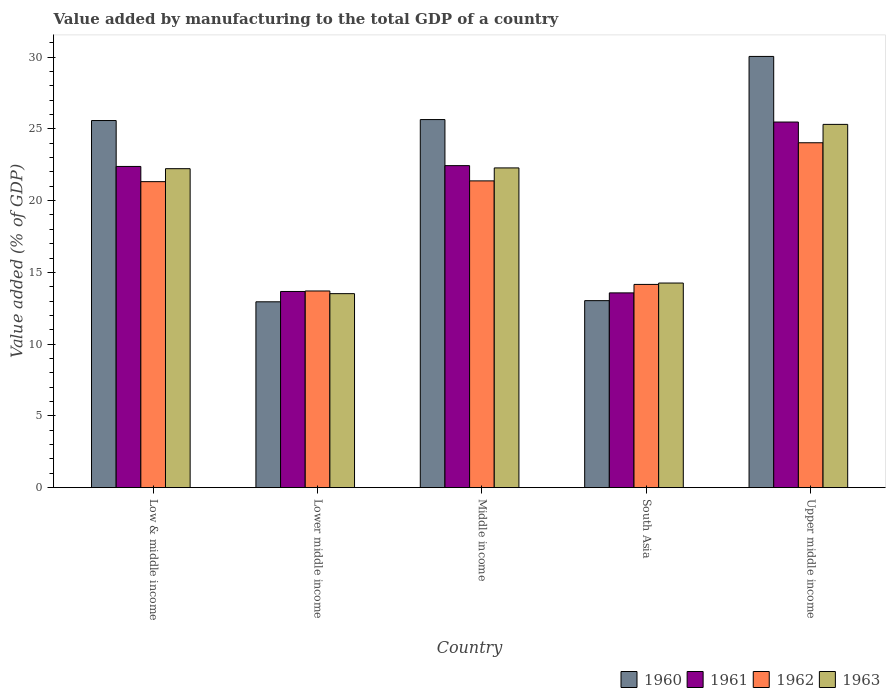How many different coloured bars are there?
Provide a succinct answer. 4. How many groups of bars are there?
Offer a terse response. 5. Are the number of bars per tick equal to the number of legend labels?
Offer a terse response. Yes. How many bars are there on the 2nd tick from the right?
Offer a very short reply. 4. What is the label of the 4th group of bars from the left?
Your answer should be very brief. South Asia. What is the value added by manufacturing to the total GDP in 1961 in Low & middle income?
Give a very brief answer. 22.38. Across all countries, what is the maximum value added by manufacturing to the total GDP in 1960?
Keep it short and to the point. 30.05. Across all countries, what is the minimum value added by manufacturing to the total GDP in 1962?
Your response must be concise. 13.7. In which country was the value added by manufacturing to the total GDP in 1961 maximum?
Offer a terse response. Upper middle income. In which country was the value added by manufacturing to the total GDP in 1963 minimum?
Your response must be concise. Lower middle income. What is the total value added by manufacturing to the total GDP in 1960 in the graph?
Your answer should be very brief. 107.25. What is the difference between the value added by manufacturing to the total GDP in 1960 in Low & middle income and that in Upper middle income?
Your answer should be very brief. -4.47. What is the difference between the value added by manufacturing to the total GDP in 1960 in South Asia and the value added by manufacturing to the total GDP in 1963 in Upper middle income?
Provide a succinct answer. -12.28. What is the average value added by manufacturing to the total GDP in 1960 per country?
Ensure brevity in your answer.  21.45. What is the difference between the value added by manufacturing to the total GDP of/in 1962 and value added by manufacturing to the total GDP of/in 1963 in Upper middle income?
Provide a succinct answer. -1.28. In how many countries, is the value added by manufacturing to the total GDP in 1963 greater than 15 %?
Keep it short and to the point. 3. What is the ratio of the value added by manufacturing to the total GDP in 1961 in Low & middle income to that in Upper middle income?
Your answer should be very brief. 0.88. Is the difference between the value added by manufacturing to the total GDP in 1962 in Low & middle income and Lower middle income greater than the difference between the value added by manufacturing to the total GDP in 1963 in Low & middle income and Lower middle income?
Keep it short and to the point. No. What is the difference between the highest and the second highest value added by manufacturing to the total GDP in 1961?
Offer a very short reply. 3.04. What is the difference between the highest and the lowest value added by manufacturing to the total GDP in 1962?
Provide a succinct answer. 10.33. Is the sum of the value added by manufacturing to the total GDP in 1962 in Lower middle income and Middle income greater than the maximum value added by manufacturing to the total GDP in 1960 across all countries?
Give a very brief answer. Yes. What does the 2nd bar from the left in Low & middle income represents?
Your answer should be very brief. 1961. Are all the bars in the graph horizontal?
Your response must be concise. No. How many countries are there in the graph?
Your response must be concise. 5. Does the graph contain any zero values?
Ensure brevity in your answer.  No. Does the graph contain grids?
Offer a very short reply. No. What is the title of the graph?
Your answer should be compact. Value added by manufacturing to the total GDP of a country. What is the label or title of the X-axis?
Make the answer very short. Country. What is the label or title of the Y-axis?
Ensure brevity in your answer.  Value added (% of GDP). What is the Value added (% of GDP) in 1960 in Low & middle income?
Your response must be concise. 25.58. What is the Value added (% of GDP) of 1961 in Low & middle income?
Your response must be concise. 22.38. What is the Value added (% of GDP) in 1962 in Low & middle income?
Make the answer very short. 21.32. What is the Value added (% of GDP) in 1963 in Low & middle income?
Make the answer very short. 22.22. What is the Value added (% of GDP) in 1960 in Lower middle income?
Offer a very short reply. 12.95. What is the Value added (% of GDP) in 1961 in Lower middle income?
Offer a very short reply. 13.67. What is the Value added (% of GDP) in 1962 in Lower middle income?
Provide a succinct answer. 13.7. What is the Value added (% of GDP) of 1963 in Lower middle income?
Provide a short and direct response. 13.52. What is the Value added (% of GDP) of 1960 in Middle income?
Offer a very short reply. 25.65. What is the Value added (% of GDP) in 1961 in Middle income?
Keep it short and to the point. 22.44. What is the Value added (% of GDP) in 1962 in Middle income?
Your answer should be compact. 21.37. What is the Value added (% of GDP) in 1963 in Middle income?
Your answer should be compact. 22.28. What is the Value added (% of GDP) in 1960 in South Asia?
Make the answer very short. 13.03. What is the Value added (% of GDP) in 1961 in South Asia?
Make the answer very short. 13.57. What is the Value added (% of GDP) in 1962 in South Asia?
Make the answer very short. 14.16. What is the Value added (% of GDP) of 1963 in South Asia?
Give a very brief answer. 14.26. What is the Value added (% of GDP) of 1960 in Upper middle income?
Ensure brevity in your answer.  30.05. What is the Value added (% of GDP) of 1961 in Upper middle income?
Provide a succinct answer. 25.47. What is the Value added (% of GDP) of 1962 in Upper middle income?
Offer a very short reply. 24.03. What is the Value added (% of GDP) of 1963 in Upper middle income?
Keep it short and to the point. 25.31. Across all countries, what is the maximum Value added (% of GDP) of 1960?
Make the answer very short. 30.05. Across all countries, what is the maximum Value added (% of GDP) in 1961?
Provide a succinct answer. 25.47. Across all countries, what is the maximum Value added (% of GDP) in 1962?
Offer a terse response. 24.03. Across all countries, what is the maximum Value added (% of GDP) in 1963?
Your response must be concise. 25.31. Across all countries, what is the minimum Value added (% of GDP) in 1960?
Make the answer very short. 12.95. Across all countries, what is the minimum Value added (% of GDP) in 1961?
Provide a succinct answer. 13.57. Across all countries, what is the minimum Value added (% of GDP) of 1962?
Ensure brevity in your answer.  13.7. Across all countries, what is the minimum Value added (% of GDP) in 1963?
Your response must be concise. 13.52. What is the total Value added (% of GDP) of 1960 in the graph?
Make the answer very short. 107.25. What is the total Value added (% of GDP) in 1961 in the graph?
Provide a short and direct response. 97.53. What is the total Value added (% of GDP) of 1962 in the graph?
Offer a very short reply. 94.59. What is the total Value added (% of GDP) in 1963 in the graph?
Ensure brevity in your answer.  97.58. What is the difference between the Value added (% of GDP) in 1960 in Low & middle income and that in Lower middle income?
Your response must be concise. 12.63. What is the difference between the Value added (% of GDP) of 1961 in Low & middle income and that in Lower middle income?
Provide a short and direct response. 8.71. What is the difference between the Value added (% of GDP) in 1962 in Low & middle income and that in Lower middle income?
Provide a short and direct response. 7.62. What is the difference between the Value added (% of GDP) of 1963 in Low & middle income and that in Lower middle income?
Offer a very short reply. 8.71. What is the difference between the Value added (% of GDP) in 1960 in Low & middle income and that in Middle income?
Provide a short and direct response. -0.07. What is the difference between the Value added (% of GDP) in 1961 in Low & middle income and that in Middle income?
Provide a succinct answer. -0.06. What is the difference between the Value added (% of GDP) in 1962 in Low & middle income and that in Middle income?
Offer a very short reply. -0.05. What is the difference between the Value added (% of GDP) in 1963 in Low & middle income and that in Middle income?
Offer a terse response. -0.05. What is the difference between the Value added (% of GDP) of 1960 in Low & middle income and that in South Asia?
Provide a succinct answer. 12.55. What is the difference between the Value added (% of GDP) of 1961 in Low & middle income and that in South Asia?
Give a very brief answer. 8.81. What is the difference between the Value added (% of GDP) of 1962 in Low & middle income and that in South Asia?
Provide a short and direct response. 7.16. What is the difference between the Value added (% of GDP) in 1963 in Low & middle income and that in South Asia?
Your answer should be very brief. 7.97. What is the difference between the Value added (% of GDP) of 1960 in Low & middle income and that in Upper middle income?
Provide a short and direct response. -4.47. What is the difference between the Value added (% of GDP) in 1961 in Low & middle income and that in Upper middle income?
Offer a terse response. -3.09. What is the difference between the Value added (% of GDP) in 1962 in Low & middle income and that in Upper middle income?
Provide a succinct answer. -2.71. What is the difference between the Value added (% of GDP) of 1963 in Low & middle income and that in Upper middle income?
Your answer should be compact. -3.09. What is the difference between the Value added (% of GDP) of 1960 in Lower middle income and that in Middle income?
Ensure brevity in your answer.  -12.7. What is the difference between the Value added (% of GDP) of 1961 in Lower middle income and that in Middle income?
Give a very brief answer. -8.77. What is the difference between the Value added (% of GDP) in 1962 in Lower middle income and that in Middle income?
Your answer should be compact. -7.67. What is the difference between the Value added (% of GDP) of 1963 in Lower middle income and that in Middle income?
Provide a succinct answer. -8.76. What is the difference between the Value added (% of GDP) in 1960 in Lower middle income and that in South Asia?
Your response must be concise. -0.08. What is the difference between the Value added (% of GDP) in 1961 in Lower middle income and that in South Asia?
Keep it short and to the point. 0.1. What is the difference between the Value added (% of GDP) of 1962 in Lower middle income and that in South Asia?
Ensure brevity in your answer.  -0.46. What is the difference between the Value added (% of GDP) in 1963 in Lower middle income and that in South Asia?
Offer a terse response. -0.74. What is the difference between the Value added (% of GDP) in 1960 in Lower middle income and that in Upper middle income?
Offer a very short reply. -17.1. What is the difference between the Value added (% of GDP) in 1961 in Lower middle income and that in Upper middle income?
Give a very brief answer. -11.81. What is the difference between the Value added (% of GDP) of 1962 in Lower middle income and that in Upper middle income?
Your response must be concise. -10.33. What is the difference between the Value added (% of GDP) of 1963 in Lower middle income and that in Upper middle income?
Your answer should be compact. -11.79. What is the difference between the Value added (% of GDP) in 1960 in Middle income and that in South Asia?
Offer a terse response. 12.62. What is the difference between the Value added (% of GDP) in 1961 in Middle income and that in South Asia?
Give a very brief answer. 8.87. What is the difference between the Value added (% of GDP) in 1962 in Middle income and that in South Asia?
Make the answer very short. 7.21. What is the difference between the Value added (% of GDP) in 1963 in Middle income and that in South Asia?
Provide a short and direct response. 8.02. What is the difference between the Value added (% of GDP) of 1960 in Middle income and that in Upper middle income?
Ensure brevity in your answer.  -4.4. What is the difference between the Value added (% of GDP) of 1961 in Middle income and that in Upper middle income?
Offer a very short reply. -3.04. What is the difference between the Value added (% of GDP) in 1962 in Middle income and that in Upper middle income?
Provide a succinct answer. -2.66. What is the difference between the Value added (% of GDP) in 1963 in Middle income and that in Upper middle income?
Offer a terse response. -3.03. What is the difference between the Value added (% of GDP) of 1960 in South Asia and that in Upper middle income?
Ensure brevity in your answer.  -17.02. What is the difference between the Value added (% of GDP) in 1961 in South Asia and that in Upper middle income?
Give a very brief answer. -11.9. What is the difference between the Value added (% of GDP) in 1962 in South Asia and that in Upper middle income?
Provide a short and direct response. -9.87. What is the difference between the Value added (% of GDP) of 1963 in South Asia and that in Upper middle income?
Your answer should be compact. -11.05. What is the difference between the Value added (% of GDP) in 1960 in Low & middle income and the Value added (% of GDP) in 1961 in Lower middle income?
Provide a succinct answer. 11.91. What is the difference between the Value added (% of GDP) in 1960 in Low & middle income and the Value added (% of GDP) in 1962 in Lower middle income?
Your answer should be compact. 11.88. What is the difference between the Value added (% of GDP) in 1960 in Low & middle income and the Value added (% of GDP) in 1963 in Lower middle income?
Your answer should be compact. 12.06. What is the difference between the Value added (% of GDP) in 1961 in Low & middle income and the Value added (% of GDP) in 1962 in Lower middle income?
Ensure brevity in your answer.  8.68. What is the difference between the Value added (% of GDP) of 1961 in Low & middle income and the Value added (% of GDP) of 1963 in Lower middle income?
Offer a very short reply. 8.86. What is the difference between the Value added (% of GDP) of 1962 in Low & middle income and the Value added (% of GDP) of 1963 in Lower middle income?
Your response must be concise. 7.8. What is the difference between the Value added (% of GDP) in 1960 in Low & middle income and the Value added (% of GDP) in 1961 in Middle income?
Make the answer very short. 3.14. What is the difference between the Value added (% of GDP) of 1960 in Low & middle income and the Value added (% of GDP) of 1962 in Middle income?
Provide a succinct answer. 4.21. What is the difference between the Value added (% of GDP) in 1960 in Low & middle income and the Value added (% of GDP) in 1963 in Middle income?
Your answer should be compact. 3.3. What is the difference between the Value added (% of GDP) in 1961 in Low & middle income and the Value added (% of GDP) in 1962 in Middle income?
Your response must be concise. 1.01. What is the difference between the Value added (% of GDP) in 1961 in Low & middle income and the Value added (% of GDP) in 1963 in Middle income?
Keep it short and to the point. 0.1. What is the difference between the Value added (% of GDP) in 1962 in Low & middle income and the Value added (% of GDP) in 1963 in Middle income?
Your answer should be very brief. -0.96. What is the difference between the Value added (% of GDP) of 1960 in Low & middle income and the Value added (% of GDP) of 1961 in South Asia?
Your answer should be compact. 12.01. What is the difference between the Value added (% of GDP) in 1960 in Low & middle income and the Value added (% of GDP) in 1962 in South Asia?
Ensure brevity in your answer.  11.42. What is the difference between the Value added (% of GDP) of 1960 in Low & middle income and the Value added (% of GDP) of 1963 in South Asia?
Your answer should be very brief. 11.32. What is the difference between the Value added (% of GDP) of 1961 in Low & middle income and the Value added (% of GDP) of 1962 in South Asia?
Give a very brief answer. 8.22. What is the difference between the Value added (% of GDP) in 1961 in Low & middle income and the Value added (% of GDP) in 1963 in South Asia?
Your response must be concise. 8.12. What is the difference between the Value added (% of GDP) of 1962 in Low & middle income and the Value added (% of GDP) of 1963 in South Asia?
Ensure brevity in your answer.  7.06. What is the difference between the Value added (% of GDP) in 1960 in Low & middle income and the Value added (% of GDP) in 1961 in Upper middle income?
Your answer should be compact. 0.11. What is the difference between the Value added (% of GDP) of 1960 in Low & middle income and the Value added (% of GDP) of 1962 in Upper middle income?
Provide a short and direct response. 1.55. What is the difference between the Value added (% of GDP) of 1960 in Low & middle income and the Value added (% of GDP) of 1963 in Upper middle income?
Offer a very short reply. 0.27. What is the difference between the Value added (% of GDP) of 1961 in Low & middle income and the Value added (% of GDP) of 1962 in Upper middle income?
Provide a succinct answer. -1.65. What is the difference between the Value added (% of GDP) of 1961 in Low & middle income and the Value added (% of GDP) of 1963 in Upper middle income?
Your answer should be compact. -2.93. What is the difference between the Value added (% of GDP) of 1962 in Low & middle income and the Value added (% of GDP) of 1963 in Upper middle income?
Make the answer very short. -3.99. What is the difference between the Value added (% of GDP) in 1960 in Lower middle income and the Value added (% of GDP) in 1961 in Middle income?
Offer a terse response. -9.49. What is the difference between the Value added (% of GDP) in 1960 in Lower middle income and the Value added (% of GDP) in 1962 in Middle income?
Make the answer very short. -8.43. What is the difference between the Value added (% of GDP) in 1960 in Lower middle income and the Value added (% of GDP) in 1963 in Middle income?
Offer a terse response. -9.33. What is the difference between the Value added (% of GDP) of 1961 in Lower middle income and the Value added (% of GDP) of 1962 in Middle income?
Your answer should be very brief. -7.71. What is the difference between the Value added (% of GDP) of 1961 in Lower middle income and the Value added (% of GDP) of 1963 in Middle income?
Your answer should be compact. -8.61. What is the difference between the Value added (% of GDP) of 1962 in Lower middle income and the Value added (% of GDP) of 1963 in Middle income?
Your answer should be compact. -8.57. What is the difference between the Value added (% of GDP) of 1960 in Lower middle income and the Value added (% of GDP) of 1961 in South Asia?
Offer a very short reply. -0.62. What is the difference between the Value added (% of GDP) of 1960 in Lower middle income and the Value added (% of GDP) of 1962 in South Asia?
Your response must be concise. -1.21. What is the difference between the Value added (% of GDP) in 1960 in Lower middle income and the Value added (% of GDP) in 1963 in South Asia?
Provide a succinct answer. -1.31. What is the difference between the Value added (% of GDP) of 1961 in Lower middle income and the Value added (% of GDP) of 1962 in South Asia?
Your answer should be very brief. -0.49. What is the difference between the Value added (% of GDP) of 1961 in Lower middle income and the Value added (% of GDP) of 1963 in South Asia?
Provide a short and direct response. -0.59. What is the difference between the Value added (% of GDP) in 1962 in Lower middle income and the Value added (% of GDP) in 1963 in South Asia?
Offer a terse response. -0.55. What is the difference between the Value added (% of GDP) of 1960 in Lower middle income and the Value added (% of GDP) of 1961 in Upper middle income?
Offer a very short reply. -12.53. What is the difference between the Value added (% of GDP) in 1960 in Lower middle income and the Value added (% of GDP) in 1962 in Upper middle income?
Give a very brief answer. -11.08. What is the difference between the Value added (% of GDP) of 1960 in Lower middle income and the Value added (% of GDP) of 1963 in Upper middle income?
Offer a terse response. -12.36. What is the difference between the Value added (% of GDP) of 1961 in Lower middle income and the Value added (% of GDP) of 1962 in Upper middle income?
Your answer should be compact. -10.36. What is the difference between the Value added (% of GDP) of 1961 in Lower middle income and the Value added (% of GDP) of 1963 in Upper middle income?
Provide a succinct answer. -11.64. What is the difference between the Value added (% of GDP) of 1962 in Lower middle income and the Value added (% of GDP) of 1963 in Upper middle income?
Your answer should be compact. -11.61. What is the difference between the Value added (% of GDP) of 1960 in Middle income and the Value added (% of GDP) of 1961 in South Asia?
Your answer should be compact. 12.08. What is the difference between the Value added (% of GDP) in 1960 in Middle income and the Value added (% of GDP) in 1962 in South Asia?
Make the answer very short. 11.49. What is the difference between the Value added (% of GDP) of 1960 in Middle income and the Value added (% of GDP) of 1963 in South Asia?
Ensure brevity in your answer.  11.39. What is the difference between the Value added (% of GDP) in 1961 in Middle income and the Value added (% of GDP) in 1962 in South Asia?
Your answer should be very brief. 8.28. What is the difference between the Value added (% of GDP) of 1961 in Middle income and the Value added (% of GDP) of 1963 in South Asia?
Offer a terse response. 8.18. What is the difference between the Value added (% of GDP) of 1962 in Middle income and the Value added (% of GDP) of 1963 in South Asia?
Your response must be concise. 7.12. What is the difference between the Value added (% of GDP) in 1960 in Middle income and the Value added (% of GDP) in 1961 in Upper middle income?
Your answer should be compact. 0.17. What is the difference between the Value added (% of GDP) in 1960 in Middle income and the Value added (% of GDP) in 1962 in Upper middle income?
Your answer should be very brief. 1.62. What is the difference between the Value added (% of GDP) of 1960 in Middle income and the Value added (% of GDP) of 1963 in Upper middle income?
Your answer should be compact. 0.34. What is the difference between the Value added (% of GDP) of 1961 in Middle income and the Value added (% of GDP) of 1962 in Upper middle income?
Offer a terse response. -1.59. What is the difference between the Value added (% of GDP) of 1961 in Middle income and the Value added (% of GDP) of 1963 in Upper middle income?
Give a very brief answer. -2.87. What is the difference between the Value added (% of GDP) in 1962 in Middle income and the Value added (% of GDP) in 1963 in Upper middle income?
Keep it short and to the point. -3.94. What is the difference between the Value added (% of GDP) of 1960 in South Asia and the Value added (% of GDP) of 1961 in Upper middle income?
Make the answer very short. -12.44. What is the difference between the Value added (% of GDP) in 1960 in South Asia and the Value added (% of GDP) in 1962 in Upper middle income?
Your response must be concise. -11. What is the difference between the Value added (% of GDP) in 1960 in South Asia and the Value added (% of GDP) in 1963 in Upper middle income?
Provide a succinct answer. -12.28. What is the difference between the Value added (% of GDP) of 1961 in South Asia and the Value added (% of GDP) of 1962 in Upper middle income?
Provide a short and direct response. -10.46. What is the difference between the Value added (% of GDP) of 1961 in South Asia and the Value added (% of GDP) of 1963 in Upper middle income?
Your answer should be compact. -11.74. What is the difference between the Value added (% of GDP) of 1962 in South Asia and the Value added (% of GDP) of 1963 in Upper middle income?
Your response must be concise. -11.15. What is the average Value added (% of GDP) of 1960 per country?
Make the answer very short. 21.45. What is the average Value added (% of GDP) of 1961 per country?
Offer a very short reply. 19.51. What is the average Value added (% of GDP) in 1962 per country?
Provide a succinct answer. 18.92. What is the average Value added (% of GDP) of 1963 per country?
Make the answer very short. 19.52. What is the difference between the Value added (% of GDP) in 1960 and Value added (% of GDP) in 1961 in Low & middle income?
Keep it short and to the point. 3.2. What is the difference between the Value added (% of GDP) in 1960 and Value added (% of GDP) in 1962 in Low & middle income?
Your response must be concise. 4.26. What is the difference between the Value added (% of GDP) in 1960 and Value added (% of GDP) in 1963 in Low & middle income?
Provide a succinct answer. 3.35. What is the difference between the Value added (% of GDP) of 1961 and Value added (% of GDP) of 1962 in Low & middle income?
Your response must be concise. 1.06. What is the difference between the Value added (% of GDP) in 1961 and Value added (% of GDP) in 1963 in Low & middle income?
Your response must be concise. 0.16. What is the difference between the Value added (% of GDP) of 1962 and Value added (% of GDP) of 1963 in Low & middle income?
Give a very brief answer. -0.9. What is the difference between the Value added (% of GDP) of 1960 and Value added (% of GDP) of 1961 in Lower middle income?
Give a very brief answer. -0.72. What is the difference between the Value added (% of GDP) in 1960 and Value added (% of GDP) in 1962 in Lower middle income?
Provide a succinct answer. -0.75. What is the difference between the Value added (% of GDP) in 1960 and Value added (% of GDP) in 1963 in Lower middle income?
Offer a terse response. -0.57. What is the difference between the Value added (% of GDP) in 1961 and Value added (% of GDP) in 1962 in Lower middle income?
Your response must be concise. -0.04. What is the difference between the Value added (% of GDP) of 1961 and Value added (% of GDP) of 1963 in Lower middle income?
Your answer should be compact. 0.15. What is the difference between the Value added (% of GDP) in 1962 and Value added (% of GDP) in 1963 in Lower middle income?
Provide a short and direct response. 0.19. What is the difference between the Value added (% of GDP) in 1960 and Value added (% of GDP) in 1961 in Middle income?
Offer a terse response. 3.21. What is the difference between the Value added (% of GDP) in 1960 and Value added (% of GDP) in 1962 in Middle income?
Provide a succinct answer. 4.27. What is the difference between the Value added (% of GDP) in 1960 and Value added (% of GDP) in 1963 in Middle income?
Your answer should be very brief. 3.37. What is the difference between the Value added (% of GDP) in 1961 and Value added (% of GDP) in 1962 in Middle income?
Your answer should be very brief. 1.06. What is the difference between the Value added (% of GDP) of 1961 and Value added (% of GDP) of 1963 in Middle income?
Your answer should be very brief. 0.16. What is the difference between the Value added (% of GDP) in 1962 and Value added (% of GDP) in 1963 in Middle income?
Your answer should be very brief. -0.9. What is the difference between the Value added (% of GDP) of 1960 and Value added (% of GDP) of 1961 in South Asia?
Offer a very short reply. -0.54. What is the difference between the Value added (% of GDP) of 1960 and Value added (% of GDP) of 1962 in South Asia?
Provide a short and direct response. -1.13. What is the difference between the Value added (% of GDP) in 1960 and Value added (% of GDP) in 1963 in South Asia?
Provide a short and direct response. -1.23. What is the difference between the Value added (% of GDP) in 1961 and Value added (% of GDP) in 1962 in South Asia?
Provide a succinct answer. -0.59. What is the difference between the Value added (% of GDP) in 1961 and Value added (% of GDP) in 1963 in South Asia?
Your answer should be very brief. -0.69. What is the difference between the Value added (% of GDP) of 1962 and Value added (% of GDP) of 1963 in South Asia?
Give a very brief answer. -0.1. What is the difference between the Value added (% of GDP) in 1960 and Value added (% of GDP) in 1961 in Upper middle income?
Keep it short and to the point. 4.57. What is the difference between the Value added (% of GDP) of 1960 and Value added (% of GDP) of 1962 in Upper middle income?
Offer a very short reply. 6.01. What is the difference between the Value added (% of GDP) in 1960 and Value added (% of GDP) in 1963 in Upper middle income?
Offer a very short reply. 4.73. What is the difference between the Value added (% of GDP) in 1961 and Value added (% of GDP) in 1962 in Upper middle income?
Your answer should be very brief. 1.44. What is the difference between the Value added (% of GDP) of 1961 and Value added (% of GDP) of 1963 in Upper middle income?
Give a very brief answer. 0.16. What is the difference between the Value added (% of GDP) of 1962 and Value added (% of GDP) of 1963 in Upper middle income?
Provide a short and direct response. -1.28. What is the ratio of the Value added (% of GDP) of 1960 in Low & middle income to that in Lower middle income?
Provide a succinct answer. 1.98. What is the ratio of the Value added (% of GDP) of 1961 in Low & middle income to that in Lower middle income?
Your response must be concise. 1.64. What is the ratio of the Value added (% of GDP) of 1962 in Low & middle income to that in Lower middle income?
Ensure brevity in your answer.  1.56. What is the ratio of the Value added (% of GDP) of 1963 in Low & middle income to that in Lower middle income?
Your response must be concise. 1.64. What is the ratio of the Value added (% of GDP) in 1960 in Low & middle income to that in Middle income?
Offer a terse response. 1. What is the ratio of the Value added (% of GDP) in 1962 in Low & middle income to that in Middle income?
Offer a very short reply. 1. What is the ratio of the Value added (% of GDP) of 1963 in Low & middle income to that in Middle income?
Make the answer very short. 1. What is the ratio of the Value added (% of GDP) of 1960 in Low & middle income to that in South Asia?
Your response must be concise. 1.96. What is the ratio of the Value added (% of GDP) in 1961 in Low & middle income to that in South Asia?
Your response must be concise. 1.65. What is the ratio of the Value added (% of GDP) of 1962 in Low & middle income to that in South Asia?
Give a very brief answer. 1.51. What is the ratio of the Value added (% of GDP) of 1963 in Low & middle income to that in South Asia?
Make the answer very short. 1.56. What is the ratio of the Value added (% of GDP) of 1960 in Low & middle income to that in Upper middle income?
Your response must be concise. 0.85. What is the ratio of the Value added (% of GDP) of 1961 in Low & middle income to that in Upper middle income?
Provide a short and direct response. 0.88. What is the ratio of the Value added (% of GDP) of 1962 in Low & middle income to that in Upper middle income?
Offer a very short reply. 0.89. What is the ratio of the Value added (% of GDP) of 1963 in Low & middle income to that in Upper middle income?
Keep it short and to the point. 0.88. What is the ratio of the Value added (% of GDP) in 1960 in Lower middle income to that in Middle income?
Keep it short and to the point. 0.5. What is the ratio of the Value added (% of GDP) of 1961 in Lower middle income to that in Middle income?
Provide a succinct answer. 0.61. What is the ratio of the Value added (% of GDP) in 1962 in Lower middle income to that in Middle income?
Ensure brevity in your answer.  0.64. What is the ratio of the Value added (% of GDP) of 1963 in Lower middle income to that in Middle income?
Provide a succinct answer. 0.61. What is the ratio of the Value added (% of GDP) in 1962 in Lower middle income to that in South Asia?
Your answer should be compact. 0.97. What is the ratio of the Value added (% of GDP) in 1963 in Lower middle income to that in South Asia?
Give a very brief answer. 0.95. What is the ratio of the Value added (% of GDP) in 1960 in Lower middle income to that in Upper middle income?
Your answer should be compact. 0.43. What is the ratio of the Value added (% of GDP) in 1961 in Lower middle income to that in Upper middle income?
Offer a terse response. 0.54. What is the ratio of the Value added (% of GDP) in 1962 in Lower middle income to that in Upper middle income?
Your answer should be compact. 0.57. What is the ratio of the Value added (% of GDP) of 1963 in Lower middle income to that in Upper middle income?
Provide a succinct answer. 0.53. What is the ratio of the Value added (% of GDP) of 1960 in Middle income to that in South Asia?
Give a very brief answer. 1.97. What is the ratio of the Value added (% of GDP) in 1961 in Middle income to that in South Asia?
Give a very brief answer. 1.65. What is the ratio of the Value added (% of GDP) in 1962 in Middle income to that in South Asia?
Provide a short and direct response. 1.51. What is the ratio of the Value added (% of GDP) in 1963 in Middle income to that in South Asia?
Give a very brief answer. 1.56. What is the ratio of the Value added (% of GDP) of 1960 in Middle income to that in Upper middle income?
Make the answer very short. 0.85. What is the ratio of the Value added (% of GDP) of 1961 in Middle income to that in Upper middle income?
Ensure brevity in your answer.  0.88. What is the ratio of the Value added (% of GDP) in 1962 in Middle income to that in Upper middle income?
Offer a very short reply. 0.89. What is the ratio of the Value added (% of GDP) of 1963 in Middle income to that in Upper middle income?
Give a very brief answer. 0.88. What is the ratio of the Value added (% of GDP) of 1960 in South Asia to that in Upper middle income?
Offer a terse response. 0.43. What is the ratio of the Value added (% of GDP) of 1961 in South Asia to that in Upper middle income?
Your response must be concise. 0.53. What is the ratio of the Value added (% of GDP) of 1962 in South Asia to that in Upper middle income?
Your answer should be compact. 0.59. What is the ratio of the Value added (% of GDP) of 1963 in South Asia to that in Upper middle income?
Ensure brevity in your answer.  0.56. What is the difference between the highest and the second highest Value added (% of GDP) of 1960?
Offer a terse response. 4.4. What is the difference between the highest and the second highest Value added (% of GDP) of 1961?
Provide a succinct answer. 3.04. What is the difference between the highest and the second highest Value added (% of GDP) in 1962?
Your answer should be compact. 2.66. What is the difference between the highest and the second highest Value added (% of GDP) of 1963?
Keep it short and to the point. 3.03. What is the difference between the highest and the lowest Value added (% of GDP) of 1960?
Make the answer very short. 17.1. What is the difference between the highest and the lowest Value added (% of GDP) in 1961?
Make the answer very short. 11.9. What is the difference between the highest and the lowest Value added (% of GDP) in 1962?
Ensure brevity in your answer.  10.33. What is the difference between the highest and the lowest Value added (% of GDP) of 1963?
Provide a short and direct response. 11.79. 